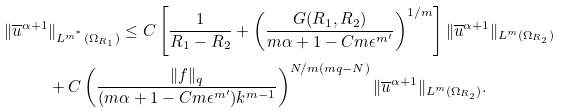<formula> <loc_0><loc_0><loc_500><loc_500>\| \overline { u } ^ { \alpha + 1 } & \| _ { L ^ { m ^ { ^ { * } } } ( \Omega _ { R _ { 1 } } ) } \leq C \left [ \frac { 1 } { R _ { 1 } - R _ { 2 } } + \left ( \frac { G ( R _ { 1 } , R _ { 2 } ) } { m \alpha + 1 - C m \epsilon ^ { m ^ { \prime } } } \right ) ^ { 1 / m } \right ] \| \overline { u } ^ { \alpha + 1 } \| _ { L ^ { m } ( \Omega _ { R _ { 2 } } ) } \\ & + C \left ( \frac { \| f \| _ { q } } { ( m \alpha + 1 - C m \epsilon ^ { m ^ { \prime } } ) k ^ { m - 1 } } \right ) ^ { N / m ( m q - N ) } \| \overline { u } ^ { \alpha + 1 } \| _ { L ^ { m } ( \Omega _ { R _ { 2 } } ) } .</formula> 